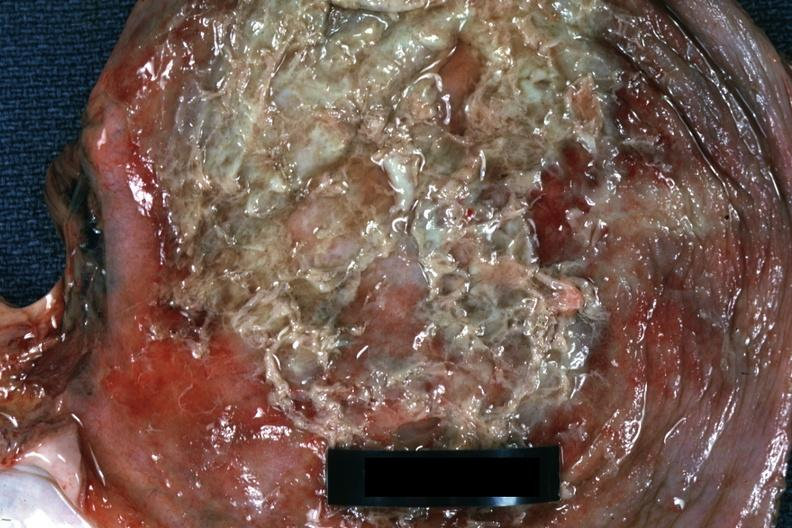what is present?
Answer the question using a single word or phrase. Soft tissue 